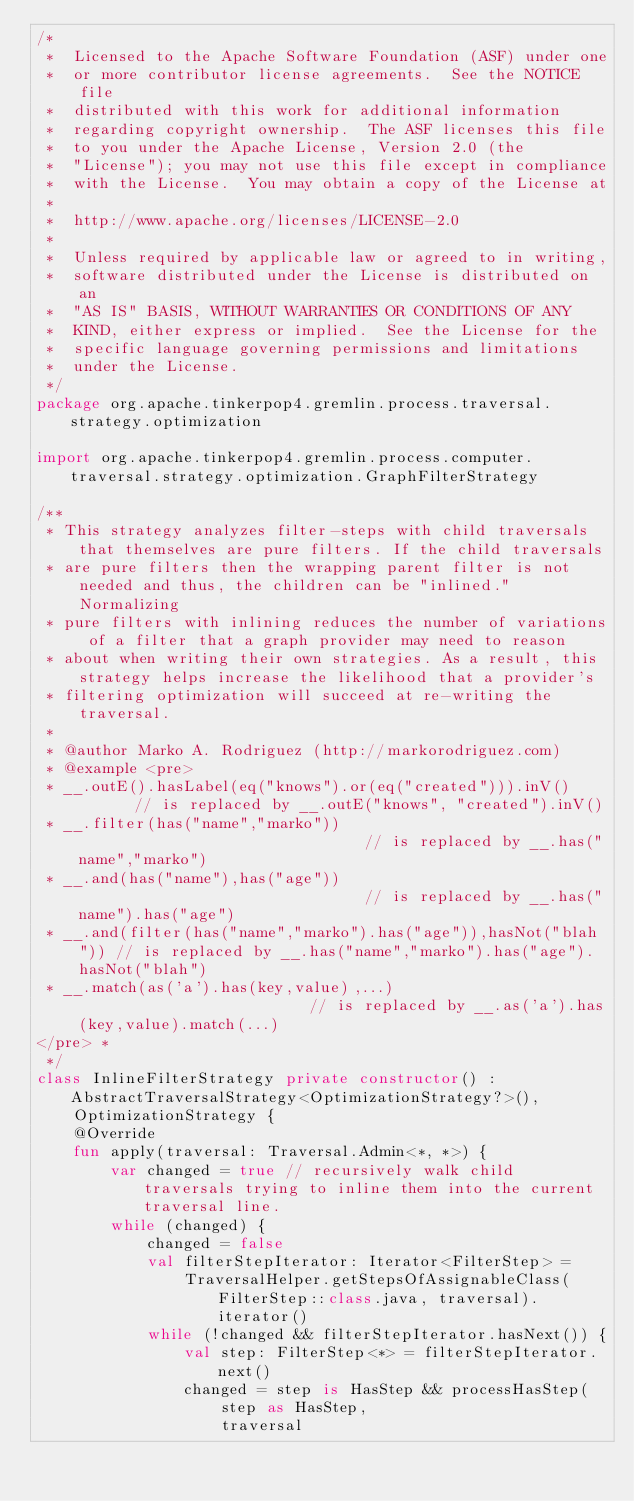Convert code to text. <code><loc_0><loc_0><loc_500><loc_500><_Kotlin_>/*
 *  Licensed to the Apache Software Foundation (ASF) under one
 *  or more contributor license agreements.  See the NOTICE file
 *  distributed with this work for additional information
 *  regarding copyright ownership.  The ASF licenses this file
 *  to you under the Apache License, Version 2.0 (the
 *  "License"); you may not use this file except in compliance
 *  with the License.  You may obtain a copy of the License at
 *
 *  http://www.apache.org/licenses/LICENSE-2.0
 *
 *  Unless required by applicable law or agreed to in writing,
 *  software distributed under the License is distributed on an
 *  "AS IS" BASIS, WITHOUT WARRANTIES OR CONDITIONS OF ANY
 *  KIND, either express or implied.  See the License for the
 *  specific language governing permissions and limitations
 *  under the License.
 */
package org.apache.tinkerpop4.gremlin.process.traversal.strategy.optimization

import org.apache.tinkerpop4.gremlin.process.computer.traversal.strategy.optimization.GraphFilterStrategy

/**
 * This strategy analyzes filter-steps with child traversals that themselves are pure filters. If the child traversals
 * are pure filters then the wrapping parent filter is not needed and thus, the children can be "inlined." Normalizing
 * pure filters with inlining reduces the number of variations of a filter that a graph provider may need to reason
 * about when writing their own strategies. As a result, this strategy helps increase the likelihood that a provider's
 * filtering optimization will succeed at re-writing the traversal.
 *
 * @author Marko A. Rodriguez (http://markorodriguez.com)
 * @example <pre>
 * __.outE().hasLabel(eq("knows").or(eq("created"))).inV()       // is replaced by __.outE("knows", "created").inV()
 * __.filter(has("name","marko"))                                // is replaced by __.has("name","marko")
 * __.and(has("name"),has("age"))                                // is replaced by __.has("name").has("age")
 * __.and(filter(has("name","marko").has("age")),hasNot("blah")) // is replaced by __.has("name","marko").has("age").hasNot("blah")
 * __.match(as('a').has(key,value),...)                          // is replaced by __.as('a').has(key,value).match(...)
</pre> *
 */
class InlineFilterStrategy private constructor() : AbstractTraversalStrategy<OptimizationStrategy?>(),
    OptimizationStrategy {
    @Override
    fun apply(traversal: Traversal.Admin<*, *>) {
        var changed = true // recursively walk child traversals trying to inline them into the current traversal line.
        while (changed) {
            changed = false
            val filterStepIterator: Iterator<FilterStep> =
                TraversalHelper.getStepsOfAssignableClass(FilterStep::class.java, traversal).iterator()
            while (!changed && filterStepIterator.hasNext()) {
                val step: FilterStep<*> = filterStepIterator.next()
                changed = step is HasStep && processHasStep(
                    step as HasStep,
                    traversal</code> 